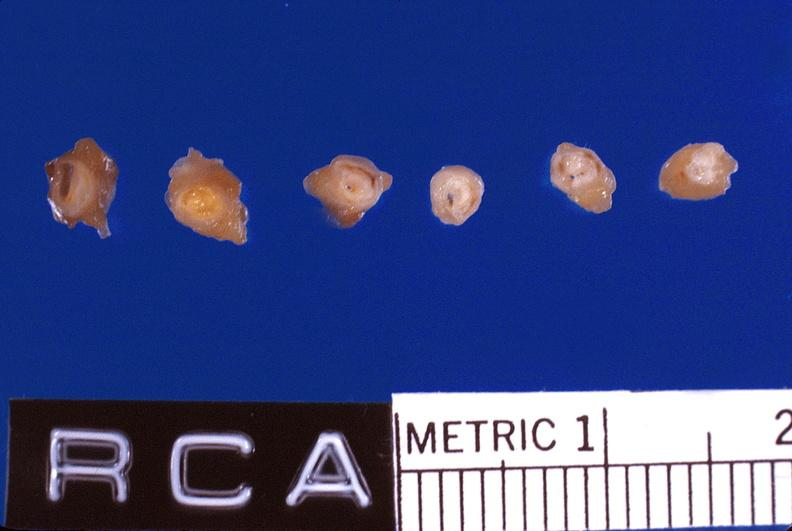where is this?
Answer the question using a single word or phrase. Vasculature 